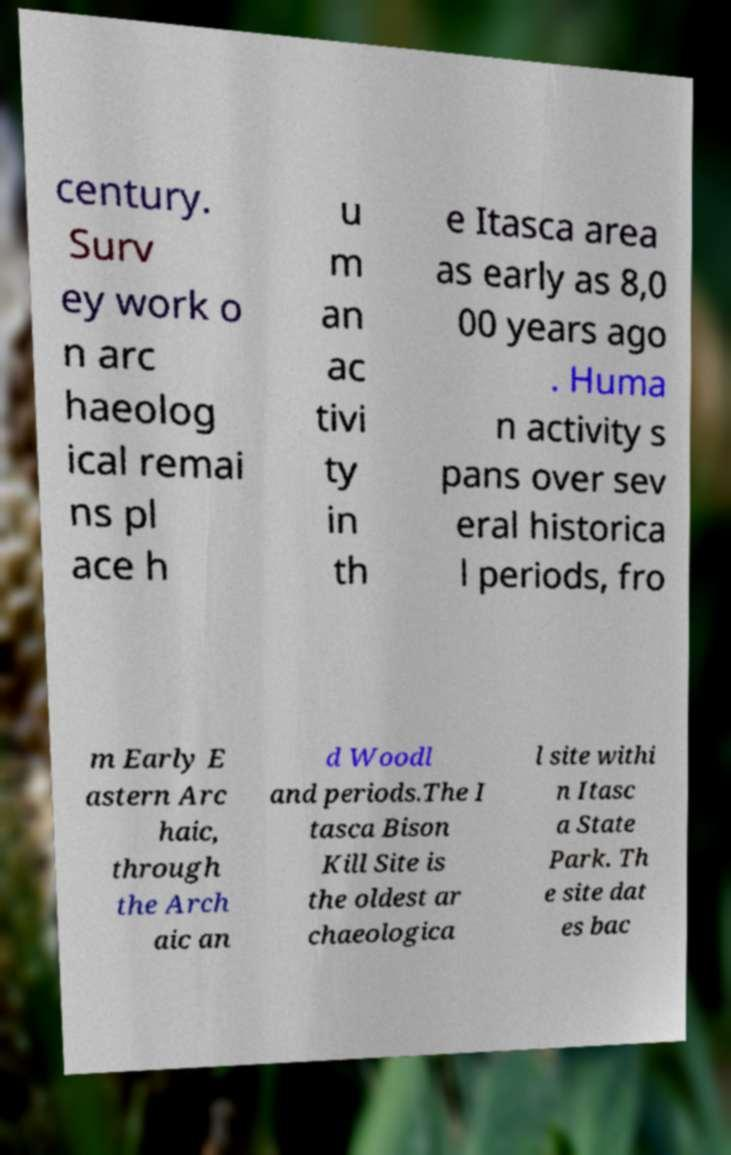Could you assist in decoding the text presented in this image and type it out clearly? century. Surv ey work o n arc haeolog ical remai ns pl ace h u m an ac tivi ty in th e Itasca area as early as 8,0 00 years ago . Huma n activity s pans over sev eral historica l periods, fro m Early E astern Arc haic, through the Arch aic an d Woodl and periods.The I tasca Bison Kill Site is the oldest ar chaeologica l site withi n Itasc a State Park. Th e site dat es bac 